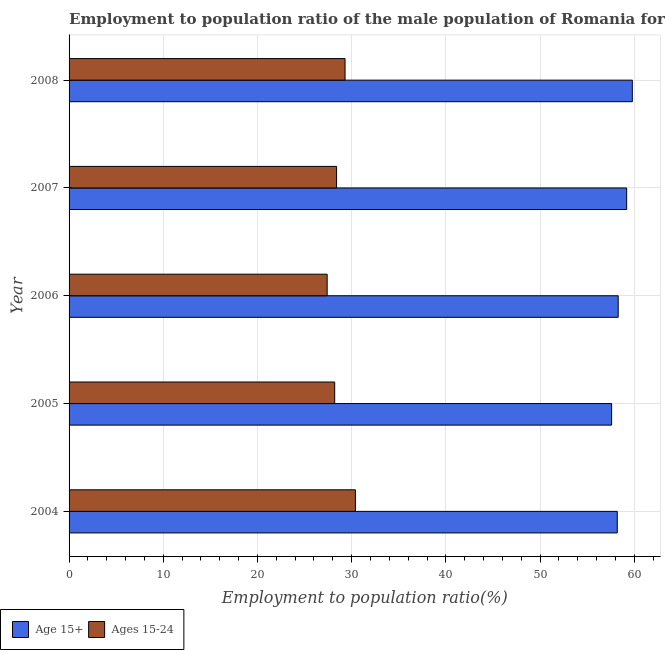Are the number of bars per tick equal to the number of legend labels?
Offer a terse response. Yes. What is the label of the 1st group of bars from the top?
Your answer should be compact. 2008. What is the employment to population ratio(age 15+) in 2007?
Ensure brevity in your answer.  59.2. Across all years, what is the maximum employment to population ratio(age 15-24)?
Give a very brief answer. 30.4. Across all years, what is the minimum employment to population ratio(age 15-24)?
Provide a short and direct response. 27.4. In which year was the employment to population ratio(age 15-24) maximum?
Your response must be concise. 2004. What is the total employment to population ratio(age 15+) in the graph?
Ensure brevity in your answer.  293.1. What is the difference between the employment to population ratio(age 15+) in 2005 and that in 2008?
Offer a terse response. -2.2. What is the difference between the employment to population ratio(age 15-24) in 2005 and the employment to population ratio(age 15+) in 2004?
Your answer should be very brief. -30. What is the average employment to population ratio(age 15-24) per year?
Provide a succinct answer. 28.74. In the year 2006, what is the difference between the employment to population ratio(age 15-24) and employment to population ratio(age 15+)?
Ensure brevity in your answer.  -30.9. What is the ratio of the employment to population ratio(age 15-24) in 2006 to that in 2007?
Give a very brief answer. 0.96. Is the employment to population ratio(age 15+) in 2004 less than that in 2007?
Provide a succinct answer. Yes. What is the difference between the highest and the second highest employment to population ratio(age 15-24)?
Keep it short and to the point. 1.1. What is the difference between the highest and the lowest employment to population ratio(age 15+)?
Ensure brevity in your answer.  2.2. Is the sum of the employment to population ratio(age 15+) in 2004 and 2008 greater than the maximum employment to population ratio(age 15-24) across all years?
Provide a succinct answer. Yes. What does the 1st bar from the top in 2006 represents?
Keep it short and to the point. Ages 15-24. What does the 1st bar from the bottom in 2004 represents?
Ensure brevity in your answer.  Age 15+. How many bars are there?
Provide a succinct answer. 10. Are all the bars in the graph horizontal?
Your answer should be very brief. Yes. How many years are there in the graph?
Your answer should be very brief. 5. What is the difference between two consecutive major ticks on the X-axis?
Your response must be concise. 10. Does the graph contain any zero values?
Ensure brevity in your answer.  No. Where does the legend appear in the graph?
Provide a succinct answer. Bottom left. How many legend labels are there?
Ensure brevity in your answer.  2. What is the title of the graph?
Provide a short and direct response. Employment to population ratio of the male population of Romania for different age-groups. What is the label or title of the Y-axis?
Make the answer very short. Year. What is the Employment to population ratio(%) of Age 15+ in 2004?
Keep it short and to the point. 58.2. What is the Employment to population ratio(%) of Ages 15-24 in 2004?
Offer a very short reply. 30.4. What is the Employment to population ratio(%) in Age 15+ in 2005?
Offer a very short reply. 57.6. What is the Employment to population ratio(%) in Ages 15-24 in 2005?
Your answer should be very brief. 28.2. What is the Employment to population ratio(%) of Age 15+ in 2006?
Your response must be concise. 58.3. What is the Employment to population ratio(%) in Ages 15-24 in 2006?
Keep it short and to the point. 27.4. What is the Employment to population ratio(%) in Age 15+ in 2007?
Offer a terse response. 59.2. What is the Employment to population ratio(%) in Ages 15-24 in 2007?
Ensure brevity in your answer.  28.4. What is the Employment to population ratio(%) in Age 15+ in 2008?
Give a very brief answer. 59.8. What is the Employment to population ratio(%) of Ages 15-24 in 2008?
Ensure brevity in your answer.  29.3. Across all years, what is the maximum Employment to population ratio(%) in Age 15+?
Offer a very short reply. 59.8. Across all years, what is the maximum Employment to population ratio(%) of Ages 15-24?
Provide a short and direct response. 30.4. Across all years, what is the minimum Employment to population ratio(%) of Age 15+?
Your answer should be very brief. 57.6. Across all years, what is the minimum Employment to population ratio(%) of Ages 15-24?
Offer a very short reply. 27.4. What is the total Employment to population ratio(%) of Age 15+ in the graph?
Ensure brevity in your answer.  293.1. What is the total Employment to population ratio(%) of Ages 15-24 in the graph?
Offer a terse response. 143.7. What is the difference between the Employment to population ratio(%) in Age 15+ in 2004 and that in 2005?
Keep it short and to the point. 0.6. What is the difference between the Employment to population ratio(%) in Ages 15-24 in 2004 and that in 2006?
Offer a terse response. 3. What is the difference between the Employment to population ratio(%) in Age 15+ in 2004 and that in 2007?
Offer a terse response. -1. What is the difference between the Employment to population ratio(%) in Ages 15-24 in 2004 and that in 2007?
Offer a terse response. 2. What is the difference between the Employment to population ratio(%) of Ages 15-24 in 2004 and that in 2008?
Offer a very short reply. 1.1. What is the difference between the Employment to population ratio(%) in Age 15+ in 2005 and that in 2006?
Offer a very short reply. -0.7. What is the difference between the Employment to population ratio(%) of Ages 15-24 in 2005 and that in 2006?
Your response must be concise. 0.8. What is the difference between the Employment to population ratio(%) of Age 15+ in 2005 and that in 2007?
Ensure brevity in your answer.  -1.6. What is the difference between the Employment to population ratio(%) of Ages 15-24 in 2005 and that in 2008?
Ensure brevity in your answer.  -1.1. What is the difference between the Employment to population ratio(%) in Ages 15-24 in 2006 and that in 2007?
Offer a terse response. -1. What is the difference between the Employment to population ratio(%) in Age 15+ in 2006 and that in 2008?
Offer a terse response. -1.5. What is the difference between the Employment to population ratio(%) of Ages 15-24 in 2007 and that in 2008?
Provide a succinct answer. -0.9. What is the difference between the Employment to population ratio(%) of Age 15+ in 2004 and the Employment to population ratio(%) of Ages 15-24 in 2006?
Ensure brevity in your answer.  30.8. What is the difference between the Employment to population ratio(%) of Age 15+ in 2004 and the Employment to population ratio(%) of Ages 15-24 in 2007?
Make the answer very short. 29.8. What is the difference between the Employment to population ratio(%) of Age 15+ in 2004 and the Employment to population ratio(%) of Ages 15-24 in 2008?
Provide a short and direct response. 28.9. What is the difference between the Employment to population ratio(%) in Age 15+ in 2005 and the Employment to population ratio(%) in Ages 15-24 in 2006?
Provide a short and direct response. 30.2. What is the difference between the Employment to population ratio(%) in Age 15+ in 2005 and the Employment to population ratio(%) in Ages 15-24 in 2007?
Make the answer very short. 29.2. What is the difference between the Employment to population ratio(%) in Age 15+ in 2005 and the Employment to population ratio(%) in Ages 15-24 in 2008?
Keep it short and to the point. 28.3. What is the difference between the Employment to population ratio(%) in Age 15+ in 2006 and the Employment to population ratio(%) in Ages 15-24 in 2007?
Provide a succinct answer. 29.9. What is the difference between the Employment to population ratio(%) in Age 15+ in 2006 and the Employment to population ratio(%) in Ages 15-24 in 2008?
Make the answer very short. 29. What is the difference between the Employment to population ratio(%) of Age 15+ in 2007 and the Employment to population ratio(%) of Ages 15-24 in 2008?
Make the answer very short. 29.9. What is the average Employment to population ratio(%) of Age 15+ per year?
Provide a short and direct response. 58.62. What is the average Employment to population ratio(%) in Ages 15-24 per year?
Your response must be concise. 28.74. In the year 2004, what is the difference between the Employment to population ratio(%) in Age 15+ and Employment to population ratio(%) in Ages 15-24?
Keep it short and to the point. 27.8. In the year 2005, what is the difference between the Employment to population ratio(%) in Age 15+ and Employment to population ratio(%) in Ages 15-24?
Your answer should be very brief. 29.4. In the year 2006, what is the difference between the Employment to population ratio(%) in Age 15+ and Employment to population ratio(%) in Ages 15-24?
Offer a very short reply. 30.9. In the year 2007, what is the difference between the Employment to population ratio(%) in Age 15+ and Employment to population ratio(%) in Ages 15-24?
Ensure brevity in your answer.  30.8. In the year 2008, what is the difference between the Employment to population ratio(%) of Age 15+ and Employment to population ratio(%) of Ages 15-24?
Ensure brevity in your answer.  30.5. What is the ratio of the Employment to population ratio(%) of Age 15+ in 2004 to that in 2005?
Make the answer very short. 1.01. What is the ratio of the Employment to population ratio(%) of Ages 15-24 in 2004 to that in 2005?
Offer a very short reply. 1.08. What is the ratio of the Employment to population ratio(%) in Ages 15-24 in 2004 to that in 2006?
Your answer should be compact. 1.11. What is the ratio of the Employment to population ratio(%) in Age 15+ in 2004 to that in 2007?
Your answer should be very brief. 0.98. What is the ratio of the Employment to population ratio(%) in Ages 15-24 in 2004 to that in 2007?
Offer a terse response. 1.07. What is the ratio of the Employment to population ratio(%) of Age 15+ in 2004 to that in 2008?
Your response must be concise. 0.97. What is the ratio of the Employment to population ratio(%) of Ages 15-24 in 2004 to that in 2008?
Your answer should be compact. 1.04. What is the ratio of the Employment to population ratio(%) in Age 15+ in 2005 to that in 2006?
Provide a succinct answer. 0.99. What is the ratio of the Employment to population ratio(%) of Ages 15-24 in 2005 to that in 2006?
Your response must be concise. 1.03. What is the ratio of the Employment to population ratio(%) of Ages 15-24 in 2005 to that in 2007?
Provide a short and direct response. 0.99. What is the ratio of the Employment to population ratio(%) in Age 15+ in 2005 to that in 2008?
Your answer should be very brief. 0.96. What is the ratio of the Employment to population ratio(%) in Ages 15-24 in 2005 to that in 2008?
Keep it short and to the point. 0.96. What is the ratio of the Employment to population ratio(%) in Ages 15-24 in 2006 to that in 2007?
Give a very brief answer. 0.96. What is the ratio of the Employment to population ratio(%) in Age 15+ in 2006 to that in 2008?
Offer a very short reply. 0.97. What is the ratio of the Employment to population ratio(%) of Ages 15-24 in 2006 to that in 2008?
Your answer should be very brief. 0.94. What is the ratio of the Employment to population ratio(%) of Ages 15-24 in 2007 to that in 2008?
Give a very brief answer. 0.97. What is the difference between the highest and the second highest Employment to population ratio(%) in Ages 15-24?
Your response must be concise. 1.1. What is the difference between the highest and the lowest Employment to population ratio(%) of Age 15+?
Your response must be concise. 2.2. 